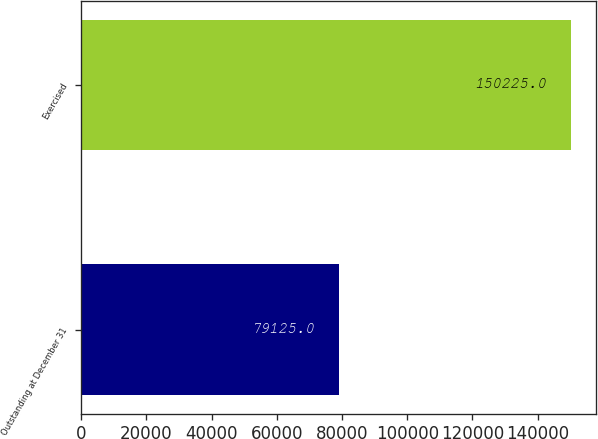<chart> <loc_0><loc_0><loc_500><loc_500><bar_chart><fcel>Outstanding at December 31<fcel>Exercised<nl><fcel>79125<fcel>150225<nl></chart> 